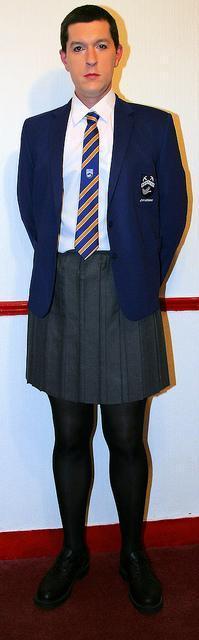How many airplane engines can you see?
Give a very brief answer. 0. 